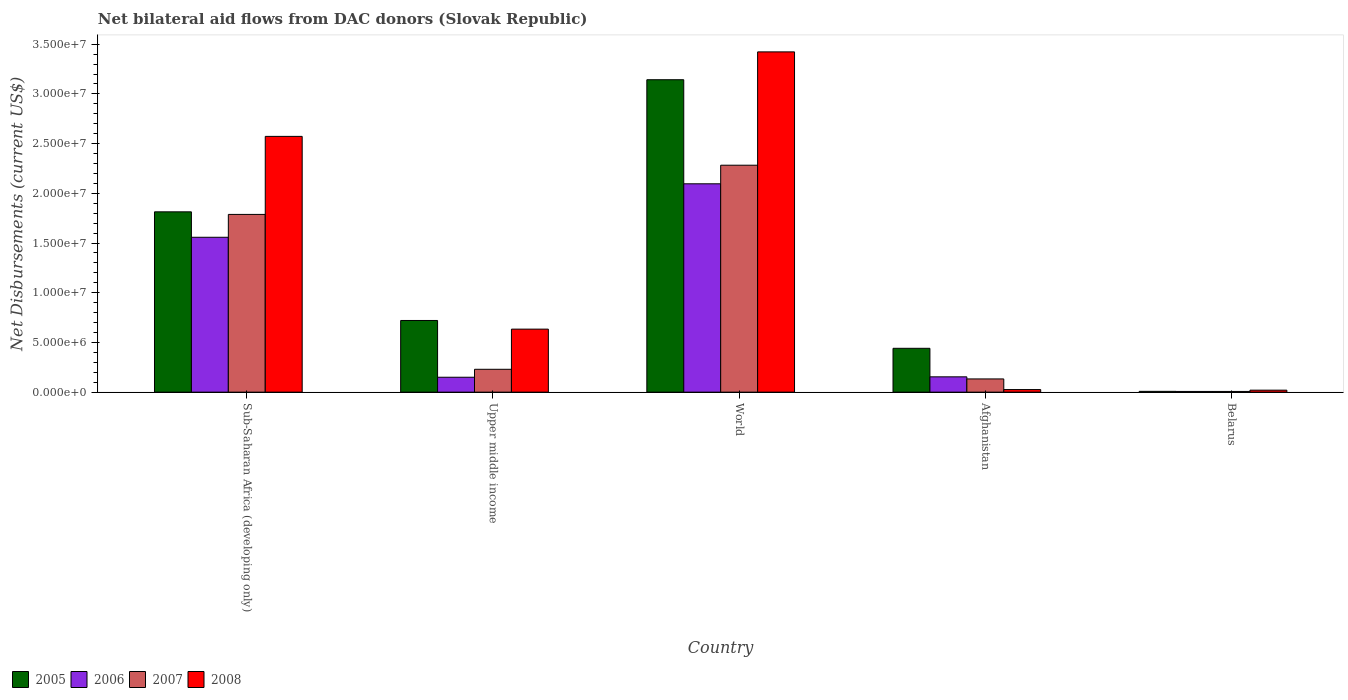How many different coloured bars are there?
Offer a terse response. 4. How many groups of bars are there?
Ensure brevity in your answer.  5. Are the number of bars per tick equal to the number of legend labels?
Ensure brevity in your answer.  Yes. Are the number of bars on each tick of the X-axis equal?
Ensure brevity in your answer.  Yes. How many bars are there on the 4th tick from the left?
Your answer should be compact. 4. What is the label of the 2nd group of bars from the left?
Keep it short and to the point. Upper middle income. In how many cases, is the number of bars for a given country not equal to the number of legend labels?
Ensure brevity in your answer.  0. What is the net bilateral aid flows in 2006 in Afghanistan?
Provide a succinct answer. 1.54e+06. Across all countries, what is the maximum net bilateral aid flows in 2006?
Provide a short and direct response. 2.10e+07. In which country was the net bilateral aid flows in 2006 minimum?
Offer a very short reply. Belarus. What is the total net bilateral aid flows in 2005 in the graph?
Provide a short and direct response. 6.13e+07. What is the difference between the net bilateral aid flows in 2007 in Afghanistan and that in Sub-Saharan Africa (developing only)?
Provide a short and direct response. -1.66e+07. What is the difference between the net bilateral aid flows in 2005 in Belarus and the net bilateral aid flows in 2007 in Afghanistan?
Your answer should be compact. -1.25e+06. What is the average net bilateral aid flows in 2005 per country?
Make the answer very short. 1.23e+07. What is the difference between the net bilateral aid flows of/in 2007 and net bilateral aid flows of/in 2006 in World?
Your answer should be very brief. 1.87e+06. What is the ratio of the net bilateral aid flows in 2006 in Afghanistan to that in Sub-Saharan Africa (developing only)?
Offer a terse response. 0.1. Is the net bilateral aid flows in 2005 in Afghanistan less than that in Belarus?
Offer a terse response. No. What is the difference between the highest and the second highest net bilateral aid flows in 2006?
Make the answer very short. 5.38e+06. What is the difference between the highest and the lowest net bilateral aid flows in 2007?
Your answer should be very brief. 2.28e+07. In how many countries, is the net bilateral aid flows in 2005 greater than the average net bilateral aid flows in 2005 taken over all countries?
Make the answer very short. 2. Is the sum of the net bilateral aid flows in 2008 in Sub-Saharan Africa (developing only) and Upper middle income greater than the maximum net bilateral aid flows in 2006 across all countries?
Ensure brevity in your answer.  Yes. Is it the case that in every country, the sum of the net bilateral aid flows in 2007 and net bilateral aid flows in 2008 is greater than the sum of net bilateral aid flows in 2006 and net bilateral aid flows in 2005?
Make the answer very short. No. What does the 1st bar from the left in Upper middle income represents?
Offer a terse response. 2005. What does the 2nd bar from the right in Sub-Saharan Africa (developing only) represents?
Offer a very short reply. 2007. How many bars are there?
Offer a terse response. 20. Are all the bars in the graph horizontal?
Ensure brevity in your answer.  No. How many countries are there in the graph?
Offer a terse response. 5. What is the difference between two consecutive major ticks on the Y-axis?
Your answer should be very brief. 5.00e+06. Are the values on the major ticks of Y-axis written in scientific E-notation?
Ensure brevity in your answer.  Yes. Does the graph contain grids?
Ensure brevity in your answer.  No. Where does the legend appear in the graph?
Ensure brevity in your answer.  Bottom left. How many legend labels are there?
Give a very brief answer. 4. How are the legend labels stacked?
Offer a terse response. Horizontal. What is the title of the graph?
Your answer should be very brief. Net bilateral aid flows from DAC donors (Slovak Republic). What is the label or title of the X-axis?
Provide a succinct answer. Country. What is the label or title of the Y-axis?
Give a very brief answer. Net Disbursements (current US$). What is the Net Disbursements (current US$) of 2005 in Sub-Saharan Africa (developing only)?
Provide a short and direct response. 1.81e+07. What is the Net Disbursements (current US$) in 2006 in Sub-Saharan Africa (developing only)?
Your answer should be very brief. 1.56e+07. What is the Net Disbursements (current US$) of 2007 in Sub-Saharan Africa (developing only)?
Make the answer very short. 1.79e+07. What is the Net Disbursements (current US$) of 2008 in Sub-Saharan Africa (developing only)?
Your response must be concise. 2.57e+07. What is the Net Disbursements (current US$) of 2005 in Upper middle income?
Give a very brief answer. 7.21e+06. What is the Net Disbursements (current US$) of 2006 in Upper middle income?
Offer a very short reply. 1.50e+06. What is the Net Disbursements (current US$) in 2007 in Upper middle income?
Your answer should be compact. 2.30e+06. What is the Net Disbursements (current US$) in 2008 in Upper middle income?
Provide a succinct answer. 6.34e+06. What is the Net Disbursements (current US$) of 2005 in World?
Your response must be concise. 3.14e+07. What is the Net Disbursements (current US$) in 2006 in World?
Give a very brief answer. 2.10e+07. What is the Net Disbursements (current US$) in 2007 in World?
Make the answer very short. 2.28e+07. What is the Net Disbursements (current US$) of 2008 in World?
Give a very brief answer. 3.42e+07. What is the Net Disbursements (current US$) of 2005 in Afghanistan?
Give a very brief answer. 4.41e+06. What is the Net Disbursements (current US$) in 2006 in Afghanistan?
Ensure brevity in your answer.  1.54e+06. What is the Net Disbursements (current US$) of 2007 in Afghanistan?
Make the answer very short. 1.33e+06. What is the Net Disbursements (current US$) in 2005 in Belarus?
Provide a short and direct response. 8.00e+04. What is the Net Disbursements (current US$) of 2008 in Belarus?
Provide a short and direct response. 2.00e+05. Across all countries, what is the maximum Net Disbursements (current US$) in 2005?
Your answer should be very brief. 3.14e+07. Across all countries, what is the maximum Net Disbursements (current US$) of 2006?
Provide a succinct answer. 2.10e+07. Across all countries, what is the maximum Net Disbursements (current US$) in 2007?
Make the answer very short. 2.28e+07. Across all countries, what is the maximum Net Disbursements (current US$) of 2008?
Make the answer very short. 3.42e+07. Across all countries, what is the minimum Net Disbursements (current US$) in 2007?
Offer a very short reply. 7.00e+04. What is the total Net Disbursements (current US$) in 2005 in the graph?
Give a very brief answer. 6.13e+07. What is the total Net Disbursements (current US$) in 2006 in the graph?
Provide a short and direct response. 3.96e+07. What is the total Net Disbursements (current US$) in 2007 in the graph?
Your answer should be compact. 4.44e+07. What is the total Net Disbursements (current US$) of 2008 in the graph?
Your answer should be very brief. 6.68e+07. What is the difference between the Net Disbursements (current US$) of 2005 in Sub-Saharan Africa (developing only) and that in Upper middle income?
Offer a terse response. 1.09e+07. What is the difference between the Net Disbursements (current US$) of 2006 in Sub-Saharan Africa (developing only) and that in Upper middle income?
Provide a succinct answer. 1.41e+07. What is the difference between the Net Disbursements (current US$) in 2007 in Sub-Saharan Africa (developing only) and that in Upper middle income?
Your answer should be very brief. 1.56e+07. What is the difference between the Net Disbursements (current US$) of 2008 in Sub-Saharan Africa (developing only) and that in Upper middle income?
Make the answer very short. 1.94e+07. What is the difference between the Net Disbursements (current US$) in 2005 in Sub-Saharan Africa (developing only) and that in World?
Ensure brevity in your answer.  -1.33e+07. What is the difference between the Net Disbursements (current US$) of 2006 in Sub-Saharan Africa (developing only) and that in World?
Your answer should be very brief. -5.38e+06. What is the difference between the Net Disbursements (current US$) of 2007 in Sub-Saharan Africa (developing only) and that in World?
Give a very brief answer. -4.95e+06. What is the difference between the Net Disbursements (current US$) of 2008 in Sub-Saharan Africa (developing only) and that in World?
Your answer should be compact. -8.50e+06. What is the difference between the Net Disbursements (current US$) of 2005 in Sub-Saharan Africa (developing only) and that in Afghanistan?
Your response must be concise. 1.37e+07. What is the difference between the Net Disbursements (current US$) in 2006 in Sub-Saharan Africa (developing only) and that in Afghanistan?
Ensure brevity in your answer.  1.40e+07. What is the difference between the Net Disbursements (current US$) in 2007 in Sub-Saharan Africa (developing only) and that in Afghanistan?
Provide a short and direct response. 1.66e+07. What is the difference between the Net Disbursements (current US$) in 2008 in Sub-Saharan Africa (developing only) and that in Afghanistan?
Ensure brevity in your answer.  2.55e+07. What is the difference between the Net Disbursements (current US$) in 2005 in Sub-Saharan Africa (developing only) and that in Belarus?
Keep it short and to the point. 1.81e+07. What is the difference between the Net Disbursements (current US$) in 2006 in Sub-Saharan Africa (developing only) and that in Belarus?
Make the answer very short. 1.55e+07. What is the difference between the Net Disbursements (current US$) in 2007 in Sub-Saharan Africa (developing only) and that in Belarus?
Your answer should be compact. 1.78e+07. What is the difference between the Net Disbursements (current US$) of 2008 in Sub-Saharan Africa (developing only) and that in Belarus?
Your answer should be very brief. 2.55e+07. What is the difference between the Net Disbursements (current US$) of 2005 in Upper middle income and that in World?
Offer a very short reply. -2.42e+07. What is the difference between the Net Disbursements (current US$) of 2006 in Upper middle income and that in World?
Your answer should be compact. -1.95e+07. What is the difference between the Net Disbursements (current US$) of 2007 in Upper middle income and that in World?
Your answer should be compact. -2.05e+07. What is the difference between the Net Disbursements (current US$) of 2008 in Upper middle income and that in World?
Give a very brief answer. -2.79e+07. What is the difference between the Net Disbursements (current US$) in 2005 in Upper middle income and that in Afghanistan?
Provide a short and direct response. 2.80e+06. What is the difference between the Net Disbursements (current US$) of 2007 in Upper middle income and that in Afghanistan?
Your answer should be very brief. 9.70e+05. What is the difference between the Net Disbursements (current US$) in 2008 in Upper middle income and that in Afghanistan?
Provide a short and direct response. 6.08e+06. What is the difference between the Net Disbursements (current US$) of 2005 in Upper middle income and that in Belarus?
Your answer should be compact. 7.13e+06. What is the difference between the Net Disbursements (current US$) in 2006 in Upper middle income and that in Belarus?
Your answer should be very brief. 1.43e+06. What is the difference between the Net Disbursements (current US$) in 2007 in Upper middle income and that in Belarus?
Your answer should be very brief. 2.23e+06. What is the difference between the Net Disbursements (current US$) in 2008 in Upper middle income and that in Belarus?
Make the answer very short. 6.14e+06. What is the difference between the Net Disbursements (current US$) in 2005 in World and that in Afghanistan?
Your answer should be very brief. 2.70e+07. What is the difference between the Net Disbursements (current US$) of 2006 in World and that in Afghanistan?
Your response must be concise. 1.94e+07. What is the difference between the Net Disbursements (current US$) of 2007 in World and that in Afghanistan?
Offer a very short reply. 2.15e+07. What is the difference between the Net Disbursements (current US$) of 2008 in World and that in Afghanistan?
Ensure brevity in your answer.  3.40e+07. What is the difference between the Net Disbursements (current US$) in 2005 in World and that in Belarus?
Keep it short and to the point. 3.14e+07. What is the difference between the Net Disbursements (current US$) of 2006 in World and that in Belarus?
Offer a very short reply. 2.09e+07. What is the difference between the Net Disbursements (current US$) in 2007 in World and that in Belarus?
Make the answer very short. 2.28e+07. What is the difference between the Net Disbursements (current US$) of 2008 in World and that in Belarus?
Your response must be concise. 3.40e+07. What is the difference between the Net Disbursements (current US$) of 2005 in Afghanistan and that in Belarus?
Provide a succinct answer. 4.33e+06. What is the difference between the Net Disbursements (current US$) in 2006 in Afghanistan and that in Belarus?
Offer a terse response. 1.47e+06. What is the difference between the Net Disbursements (current US$) of 2007 in Afghanistan and that in Belarus?
Your response must be concise. 1.26e+06. What is the difference between the Net Disbursements (current US$) of 2005 in Sub-Saharan Africa (developing only) and the Net Disbursements (current US$) of 2006 in Upper middle income?
Give a very brief answer. 1.66e+07. What is the difference between the Net Disbursements (current US$) of 2005 in Sub-Saharan Africa (developing only) and the Net Disbursements (current US$) of 2007 in Upper middle income?
Your answer should be very brief. 1.58e+07. What is the difference between the Net Disbursements (current US$) in 2005 in Sub-Saharan Africa (developing only) and the Net Disbursements (current US$) in 2008 in Upper middle income?
Provide a succinct answer. 1.18e+07. What is the difference between the Net Disbursements (current US$) of 2006 in Sub-Saharan Africa (developing only) and the Net Disbursements (current US$) of 2007 in Upper middle income?
Make the answer very short. 1.33e+07. What is the difference between the Net Disbursements (current US$) of 2006 in Sub-Saharan Africa (developing only) and the Net Disbursements (current US$) of 2008 in Upper middle income?
Your answer should be compact. 9.24e+06. What is the difference between the Net Disbursements (current US$) in 2007 in Sub-Saharan Africa (developing only) and the Net Disbursements (current US$) in 2008 in Upper middle income?
Offer a terse response. 1.15e+07. What is the difference between the Net Disbursements (current US$) in 2005 in Sub-Saharan Africa (developing only) and the Net Disbursements (current US$) in 2006 in World?
Offer a terse response. -2.82e+06. What is the difference between the Net Disbursements (current US$) of 2005 in Sub-Saharan Africa (developing only) and the Net Disbursements (current US$) of 2007 in World?
Your answer should be very brief. -4.69e+06. What is the difference between the Net Disbursements (current US$) of 2005 in Sub-Saharan Africa (developing only) and the Net Disbursements (current US$) of 2008 in World?
Ensure brevity in your answer.  -1.61e+07. What is the difference between the Net Disbursements (current US$) in 2006 in Sub-Saharan Africa (developing only) and the Net Disbursements (current US$) in 2007 in World?
Provide a short and direct response. -7.25e+06. What is the difference between the Net Disbursements (current US$) in 2006 in Sub-Saharan Africa (developing only) and the Net Disbursements (current US$) in 2008 in World?
Your answer should be compact. -1.86e+07. What is the difference between the Net Disbursements (current US$) of 2007 in Sub-Saharan Africa (developing only) and the Net Disbursements (current US$) of 2008 in World?
Offer a very short reply. -1.64e+07. What is the difference between the Net Disbursements (current US$) in 2005 in Sub-Saharan Africa (developing only) and the Net Disbursements (current US$) in 2006 in Afghanistan?
Your answer should be very brief. 1.66e+07. What is the difference between the Net Disbursements (current US$) of 2005 in Sub-Saharan Africa (developing only) and the Net Disbursements (current US$) of 2007 in Afghanistan?
Offer a terse response. 1.68e+07. What is the difference between the Net Disbursements (current US$) of 2005 in Sub-Saharan Africa (developing only) and the Net Disbursements (current US$) of 2008 in Afghanistan?
Provide a succinct answer. 1.79e+07. What is the difference between the Net Disbursements (current US$) in 2006 in Sub-Saharan Africa (developing only) and the Net Disbursements (current US$) in 2007 in Afghanistan?
Your response must be concise. 1.42e+07. What is the difference between the Net Disbursements (current US$) in 2006 in Sub-Saharan Africa (developing only) and the Net Disbursements (current US$) in 2008 in Afghanistan?
Offer a very short reply. 1.53e+07. What is the difference between the Net Disbursements (current US$) in 2007 in Sub-Saharan Africa (developing only) and the Net Disbursements (current US$) in 2008 in Afghanistan?
Provide a succinct answer. 1.76e+07. What is the difference between the Net Disbursements (current US$) of 2005 in Sub-Saharan Africa (developing only) and the Net Disbursements (current US$) of 2006 in Belarus?
Your answer should be very brief. 1.81e+07. What is the difference between the Net Disbursements (current US$) in 2005 in Sub-Saharan Africa (developing only) and the Net Disbursements (current US$) in 2007 in Belarus?
Keep it short and to the point. 1.81e+07. What is the difference between the Net Disbursements (current US$) of 2005 in Sub-Saharan Africa (developing only) and the Net Disbursements (current US$) of 2008 in Belarus?
Offer a terse response. 1.79e+07. What is the difference between the Net Disbursements (current US$) in 2006 in Sub-Saharan Africa (developing only) and the Net Disbursements (current US$) in 2007 in Belarus?
Offer a terse response. 1.55e+07. What is the difference between the Net Disbursements (current US$) of 2006 in Sub-Saharan Africa (developing only) and the Net Disbursements (current US$) of 2008 in Belarus?
Ensure brevity in your answer.  1.54e+07. What is the difference between the Net Disbursements (current US$) in 2007 in Sub-Saharan Africa (developing only) and the Net Disbursements (current US$) in 2008 in Belarus?
Make the answer very short. 1.77e+07. What is the difference between the Net Disbursements (current US$) of 2005 in Upper middle income and the Net Disbursements (current US$) of 2006 in World?
Offer a very short reply. -1.38e+07. What is the difference between the Net Disbursements (current US$) in 2005 in Upper middle income and the Net Disbursements (current US$) in 2007 in World?
Your answer should be compact. -1.56e+07. What is the difference between the Net Disbursements (current US$) of 2005 in Upper middle income and the Net Disbursements (current US$) of 2008 in World?
Ensure brevity in your answer.  -2.70e+07. What is the difference between the Net Disbursements (current US$) of 2006 in Upper middle income and the Net Disbursements (current US$) of 2007 in World?
Make the answer very short. -2.13e+07. What is the difference between the Net Disbursements (current US$) in 2006 in Upper middle income and the Net Disbursements (current US$) in 2008 in World?
Offer a very short reply. -3.27e+07. What is the difference between the Net Disbursements (current US$) in 2007 in Upper middle income and the Net Disbursements (current US$) in 2008 in World?
Offer a very short reply. -3.19e+07. What is the difference between the Net Disbursements (current US$) of 2005 in Upper middle income and the Net Disbursements (current US$) of 2006 in Afghanistan?
Provide a short and direct response. 5.67e+06. What is the difference between the Net Disbursements (current US$) in 2005 in Upper middle income and the Net Disbursements (current US$) in 2007 in Afghanistan?
Your answer should be compact. 5.88e+06. What is the difference between the Net Disbursements (current US$) in 2005 in Upper middle income and the Net Disbursements (current US$) in 2008 in Afghanistan?
Offer a very short reply. 6.95e+06. What is the difference between the Net Disbursements (current US$) of 2006 in Upper middle income and the Net Disbursements (current US$) of 2008 in Afghanistan?
Give a very brief answer. 1.24e+06. What is the difference between the Net Disbursements (current US$) in 2007 in Upper middle income and the Net Disbursements (current US$) in 2008 in Afghanistan?
Offer a very short reply. 2.04e+06. What is the difference between the Net Disbursements (current US$) of 2005 in Upper middle income and the Net Disbursements (current US$) of 2006 in Belarus?
Offer a terse response. 7.14e+06. What is the difference between the Net Disbursements (current US$) in 2005 in Upper middle income and the Net Disbursements (current US$) in 2007 in Belarus?
Provide a short and direct response. 7.14e+06. What is the difference between the Net Disbursements (current US$) in 2005 in Upper middle income and the Net Disbursements (current US$) in 2008 in Belarus?
Give a very brief answer. 7.01e+06. What is the difference between the Net Disbursements (current US$) of 2006 in Upper middle income and the Net Disbursements (current US$) of 2007 in Belarus?
Offer a terse response. 1.43e+06. What is the difference between the Net Disbursements (current US$) in 2006 in Upper middle income and the Net Disbursements (current US$) in 2008 in Belarus?
Your response must be concise. 1.30e+06. What is the difference between the Net Disbursements (current US$) in 2007 in Upper middle income and the Net Disbursements (current US$) in 2008 in Belarus?
Your response must be concise. 2.10e+06. What is the difference between the Net Disbursements (current US$) of 2005 in World and the Net Disbursements (current US$) of 2006 in Afghanistan?
Your answer should be very brief. 2.99e+07. What is the difference between the Net Disbursements (current US$) of 2005 in World and the Net Disbursements (current US$) of 2007 in Afghanistan?
Offer a terse response. 3.01e+07. What is the difference between the Net Disbursements (current US$) in 2005 in World and the Net Disbursements (current US$) in 2008 in Afghanistan?
Your answer should be very brief. 3.12e+07. What is the difference between the Net Disbursements (current US$) of 2006 in World and the Net Disbursements (current US$) of 2007 in Afghanistan?
Offer a terse response. 1.96e+07. What is the difference between the Net Disbursements (current US$) in 2006 in World and the Net Disbursements (current US$) in 2008 in Afghanistan?
Your answer should be very brief. 2.07e+07. What is the difference between the Net Disbursements (current US$) in 2007 in World and the Net Disbursements (current US$) in 2008 in Afghanistan?
Ensure brevity in your answer.  2.26e+07. What is the difference between the Net Disbursements (current US$) in 2005 in World and the Net Disbursements (current US$) in 2006 in Belarus?
Offer a terse response. 3.14e+07. What is the difference between the Net Disbursements (current US$) in 2005 in World and the Net Disbursements (current US$) in 2007 in Belarus?
Keep it short and to the point. 3.14e+07. What is the difference between the Net Disbursements (current US$) of 2005 in World and the Net Disbursements (current US$) of 2008 in Belarus?
Your answer should be very brief. 3.12e+07. What is the difference between the Net Disbursements (current US$) in 2006 in World and the Net Disbursements (current US$) in 2007 in Belarus?
Provide a succinct answer. 2.09e+07. What is the difference between the Net Disbursements (current US$) in 2006 in World and the Net Disbursements (current US$) in 2008 in Belarus?
Ensure brevity in your answer.  2.08e+07. What is the difference between the Net Disbursements (current US$) of 2007 in World and the Net Disbursements (current US$) of 2008 in Belarus?
Ensure brevity in your answer.  2.26e+07. What is the difference between the Net Disbursements (current US$) of 2005 in Afghanistan and the Net Disbursements (current US$) of 2006 in Belarus?
Offer a very short reply. 4.34e+06. What is the difference between the Net Disbursements (current US$) in 2005 in Afghanistan and the Net Disbursements (current US$) in 2007 in Belarus?
Your response must be concise. 4.34e+06. What is the difference between the Net Disbursements (current US$) in 2005 in Afghanistan and the Net Disbursements (current US$) in 2008 in Belarus?
Give a very brief answer. 4.21e+06. What is the difference between the Net Disbursements (current US$) in 2006 in Afghanistan and the Net Disbursements (current US$) in 2007 in Belarus?
Offer a terse response. 1.47e+06. What is the difference between the Net Disbursements (current US$) in 2006 in Afghanistan and the Net Disbursements (current US$) in 2008 in Belarus?
Make the answer very short. 1.34e+06. What is the difference between the Net Disbursements (current US$) of 2007 in Afghanistan and the Net Disbursements (current US$) of 2008 in Belarus?
Offer a very short reply. 1.13e+06. What is the average Net Disbursements (current US$) of 2005 per country?
Provide a succinct answer. 1.23e+07. What is the average Net Disbursements (current US$) in 2006 per country?
Keep it short and to the point. 7.93e+06. What is the average Net Disbursements (current US$) in 2007 per country?
Make the answer very short. 8.88e+06. What is the average Net Disbursements (current US$) in 2008 per country?
Ensure brevity in your answer.  1.34e+07. What is the difference between the Net Disbursements (current US$) of 2005 and Net Disbursements (current US$) of 2006 in Sub-Saharan Africa (developing only)?
Keep it short and to the point. 2.56e+06. What is the difference between the Net Disbursements (current US$) in 2005 and Net Disbursements (current US$) in 2007 in Sub-Saharan Africa (developing only)?
Offer a very short reply. 2.60e+05. What is the difference between the Net Disbursements (current US$) in 2005 and Net Disbursements (current US$) in 2008 in Sub-Saharan Africa (developing only)?
Your response must be concise. -7.59e+06. What is the difference between the Net Disbursements (current US$) in 2006 and Net Disbursements (current US$) in 2007 in Sub-Saharan Africa (developing only)?
Keep it short and to the point. -2.30e+06. What is the difference between the Net Disbursements (current US$) of 2006 and Net Disbursements (current US$) of 2008 in Sub-Saharan Africa (developing only)?
Make the answer very short. -1.02e+07. What is the difference between the Net Disbursements (current US$) of 2007 and Net Disbursements (current US$) of 2008 in Sub-Saharan Africa (developing only)?
Make the answer very short. -7.85e+06. What is the difference between the Net Disbursements (current US$) in 2005 and Net Disbursements (current US$) in 2006 in Upper middle income?
Provide a short and direct response. 5.71e+06. What is the difference between the Net Disbursements (current US$) in 2005 and Net Disbursements (current US$) in 2007 in Upper middle income?
Ensure brevity in your answer.  4.91e+06. What is the difference between the Net Disbursements (current US$) in 2005 and Net Disbursements (current US$) in 2008 in Upper middle income?
Make the answer very short. 8.70e+05. What is the difference between the Net Disbursements (current US$) in 2006 and Net Disbursements (current US$) in 2007 in Upper middle income?
Your response must be concise. -8.00e+05. What is the difference between the Net Disbursements (current US$) in 2006 and Net Disbursements (current US$) in 2008 in Upper middle income?
Make the answer very short. -4.84e+06. What is the difference between the Net Disbursements (current US$) of 2007 and Net Disbursements (current US$) of 2008 in Upper middle income?
Offer a very short reply. -4.04e+06. What is the difference between the Net Disbursements (current US$) in 2005 and Net Disbursements (current US$) in 2006 in World?
Provide a short and direct response. 1.05e+07. What is the difference between the Net Disbursements (current US$) of 2005 and Net Disbursements (current US$) of 2007 in World?
Give a very brief answer. 8.60e+06. What is the difference between the Net Disbursements (current US$) in 2005 and Net Disbursements (current US$) in 2008 in World?
Your answer should be compact. -2.80e+06. What is the difference between the Net Disbursements (current US$) in 2006 and Net Disbursements (current US$) in 2007 in World?
Provide a succinct answer. -1.87e+06. What is the difference between the Net Disbursements (current US$) in 2006 and Net Disbursements (current US$) in 2008 in World?
Offer a very short reply. -1.33e+07. What is the difference between the Net Disbursements (current US$) in 2007 and Net Disbursements (current US$) in 2008 in World?
Keep it short and to the point. -1.14e+07. What is the difference between the Net Disbursements (current US$) in 2005 and Net Disbursements (current US$) in 2006 in Afghanistan?
Your response must be concise. 2.87e+06. What is the difference between the Net Disbursements (current US$) in 2005 and Net Disbursements (current US$) in 2007 in Afghanistan?
Your answer should be compact. 3.08e+06. What is the difference between the Net Disbursements (current US$) in 2005 and Net Disbursements (current US$) in 2008 in Afghanistan?
Your answer should be compact. 4.15e+06. What is the difference between the Net Disbursements (current US$) in 2006 and Net Disbursements (current US$) in 2007 in Afghanistan?
Offer a very short reply. 2.10e+05. What is the difference between the Net Disbursements (current US$) of 2006 and Net Disbursements (current US$) of 2008 in Afghanistan?
Give a very brief answer. 1.28e+06. What is the difference between the Net Disbursements (current US$) of 2007 and Net Disbursements (current US$) of 2008 in Afghanistan?
Offer a very short reply. 1.07e+06. What is the difference between the Net Disbursements (current US$) of 2005 and Net Disbursements (current US$) of 2006 in Belarus?
Your answer should be compact. 10000. What is the difference between the Net Disbursements (current US$) of 2007 and Net Disbursements (current US$) of 2008 in Belarus?
Ensure brevity in your answer.  -1.30e+05. What is the ratio of the Net Disbursements (current US$) in 2005 in Sub-Saharan Africa (developing only) to that in Upper middle income?
Ensure brevity in your answer.  2.52. What is the ratio of the Net Disbursements (current US$) in 2006 in Sub-Saharan Africa (developing only) to that in Upper middle income?
Give a very brief answer. 10.39. What is the ratio of the Net Disbursements (current US$) of 2007 in Sub-Saharan Africa (developing only) to that in Upper middle income?
Provide a succinct answer. 7.77. What is the ratio of the Net Disbursements (current US$) in 2008 in Sub-Saharan Africa (developing only) to that in Upper middle income?
Keep it short and to the point. 4.06. What is the ratio of the Net Disbursements (current US$) of 2005 in Sub-Saharan Africa (developing only) to that in World?
Your answer should be very brief. 0.58. What is the ratio of the Net Disbursements (current US$) in 2006 in Sub-Saharan Africa (developing only) to that in World?
Keep it short and to the point. 0.74. What is the ratio of the Net Disbursements (current US$) of 2007 in Sub-Saharan Africa (developing only) to that in World?
Give a very brief answer. 0.78. What is the ratio of the Net Disbursements (current US$) of 2008 in Sub-Saharan Africa (developing only) to that in World?
Make the answer very short. 0.75. What is the ratio of the Net Disbursements (current US$) in 2005 in Sub-Saharan Africa (developing only) to that in Afghanistan?
Give a very brief answer. 4.11. What is the ratio of the Net Disbursements (current US$) in 2006 in Sub-Saharan Africa (developing only) to that in Afghanistan?
Offer a very short reply. 10.12. What is the ratio of the Net Disbursements (current US$) of 2007 in Sub-Saharan Africa (developing only) to that in Afghanistan?
Offer a very short reply. 13.44. What is the ratio of the Net Disbursements (current US$) in 2008 in Sub-Saharan Africa (developing only) to that in Afghanistan?
Keep it short and to the point. 98.96. What is the ratio of the Net Disbursements (current US$) of 2005 in Sub-Saharan Africa (developing only) to that in Belarus?
Your answer should be very brief. 226.75. What is the ratio of the Net Disbursements (current US$) in 2006 in Sub-Saharan Africa (developing only) to that in Belarus?
Provide a succinct answer. 222.57. What is the ratio of the Net Disbursements (current US$) of 2007 in Sub-Saharan Africa (developing only) to that in Belarus?
Give a very brief answer. 255.43. What is the ratio of the Net Disbursements (current US$) in 2008 in Sub-Saharan Africa (developing only) to that in Belarus?
Keep it short and to the point. 128.65. What is the ratio of the Net Disbursements (current US$) of 2005 in Upper middle income to that in World?
Make the answer very short. 0.23. What is the ratio of the Net Disbursements (current US$) of 2006 in Upper middle income to that in World?
Make the answer very short. 0.07. What is the ratio of the Net Disbursements (current US$) in 2007 in Upper middle income to that in World?
Keep it short and to the point. 0.1. What is the ratio of the Net Disbursements (current US$) of 2008 in Upper middle income to that in World?
Your response must be concise. 0.19. What is the ratio of the Net Disbursements (current US$) in 2005 in Upper middle income to that in Afghanistan?
Ensure brevity in your answer.  1.63. What is the ratio of the Net Disbursements (current US$) of 2006 in Upper middle income to that in Afghanistan?
Give a very brief answer. 0.97. What is the ratio of the Net Disbursements (current US$) in 2007 in Upper middle income to that in Afghanistan?
Provide a succinct answer. 1.73. What is the ratio of the Net Disbursements (current US$) in 2008 in Upper middle income to that in Afghanistan?
Offer a terse response. 24.38. What is the ratio of the Net Disbursements (current US$) of 2005 in Upper middle income to that in Belarus?
Offer a terse response. 90.12. What is the ratio of the Net Disbursements (current US$) of 2006 in Upper middle income to that in Belarus?
Provide a succinct answer. 21.43. What is the ratio of the Net Disbursements (current US$) in 2007 in Upper middle income to that in Belarus?
Your response must be concise. 32.86. What is the ratio of the Net Disbursements (current US$) in 2008 in Upper middle income to that in Belarus?
Provide a succinct answer. 31.7. What is the ratio of the Net Disbursements (current US$) in 2005 in World to that in Afghanistan?
Ensure brevity in your answer.  7.13. What is the ratio of the Net Disbursements (current US$) in 2006 in World to that in Afghanistan?
Your response must be concise. 13.61. What is the ratio of the Net Disbursements (current US$) of 2007 in World to that in Afghanistan?
Make the answer very short. 17.17. What is the ratio of the Net Disbursements (current US$) of 2008 in World to that in Afghanistan?
Make the answer very short. 131.65. What is the ratio of the Net Disbursements (current US$) of 2005 in World to that in Belarus?
Give a very brief answer. 392.88. What is the ratio of the Net Disbursements (current US$) of 2006 in World to that in Belarus?
Offer a very short reply. 299.43. What is the ratio of the Net Disbursements (current US$) of 2007 in World to that in Belarus?
Keep it short and to the point. 326.14. What is the ratio of the Net Disbursements (current US$) of 2008 in World to that in Belarus?
Offer a very short reply. 171.15. What is the ratio of the Net Disbursements (current US$) in 2005 in Afghanistan to that in Belarus?
Make the answer very short. 55.12. What is the difference between the highest and the second highest Net Disbursements (current US$) of 2005?
Provide a succinct answer. 1.33e+07. What is the difference between the highest and the second highest Net Disbursements (current US$) in 2006?
Your response must be concise. 5.38e+06. What is the difference between the highest and the second highest Net Disbursements (current US$) of 2007?
Offer a very short reply. 4.95e+06. What is the difference between the highest and the second highest Net Disbursements (current US$) in 2008?
Your answer should be compact. 8.50e+06. What is the difference between the highest and the lowest Net Disbursements (current US$) of 2005?
Your answer should be very brief. 3.14e+07. What is the difference between the highest and the lowest Net Disbursements (current US$) in 2006?
Ensure brevity in your answer.  2.09e+07. What is the difference between the highest and the lowest Net Disbursements (current US$) in 2007?
Your answer should be compact. 2.28e+07. What is the difference between the highest and the lowest Net Disbursements (current US$) of 2008?
Your response must be concise. 3.40e+07. 